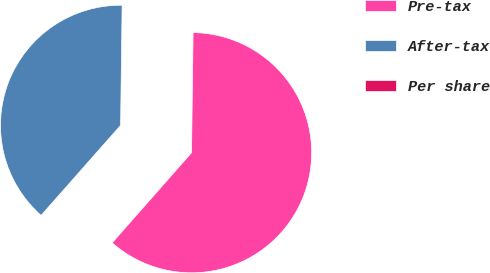Convert chart to OTSL. <chart><loc_0><loc_0><loc_500><loc_500><pie_chart><fcel>Pre-tax<fcel>After-tax<fcel>Per share<nl><fcel>61.28%<fcel>38.69%<fcel>0.02%<nl></chart> 